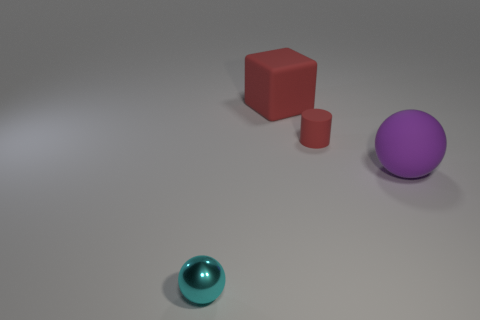Add 3 gray matte spheres. How many objects exist? 7 Subtract all cylinders. How many objects are left? 3 Subtract all large purple objects. Subtract all tiny matte cylinders. How many objects are left? 2 Add 1 red matte things. How many red matte things are left? 3 Add 1 metal objects. How many metal objects exist? 2 Subtract 1 red blocks. How many objects are left? 3 